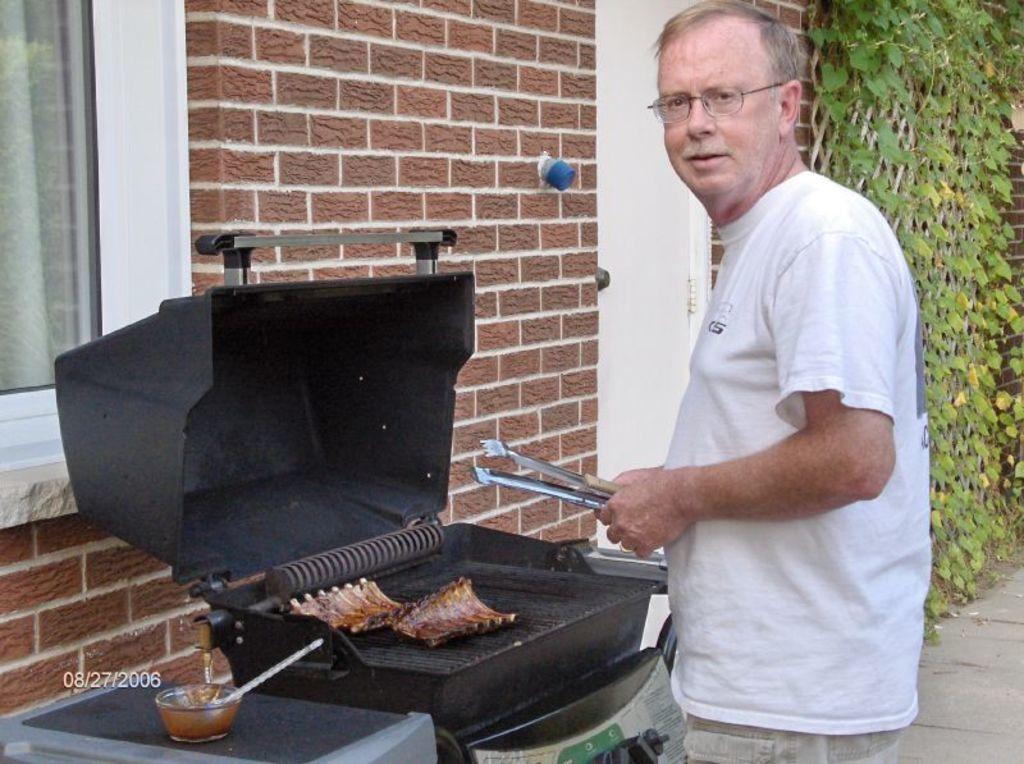In one or two sentences, can you explain what this image depicts? In this image we can see a person standing and holding an object and in front of him there is a barbecue grill with some food item and to the side there is a bowl. We can see a building and there are some creepers in the background. 